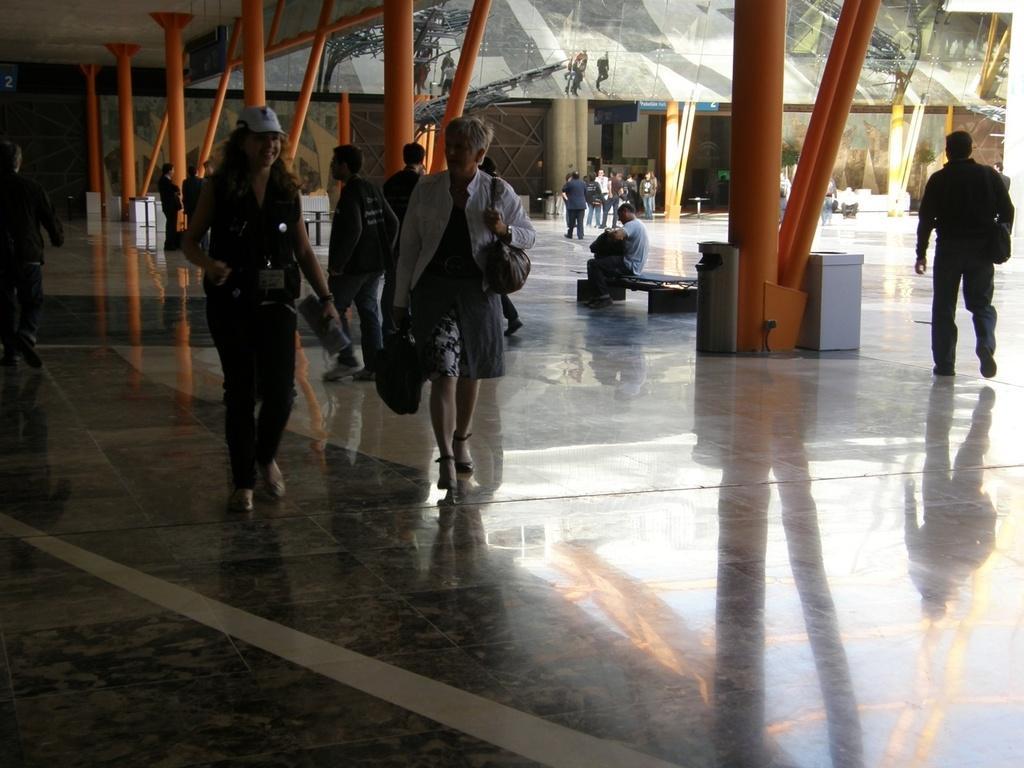Describe this image in one or two sentences. In this image there are a few people walking and there are few other people seated on a bench. 